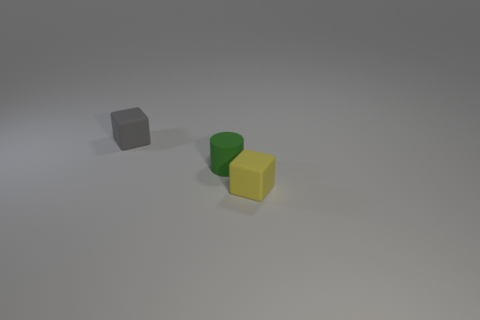Can you tell me the colors of the blocks and the cylinder? Certainly, there is a gray block, a yellow cube, and a green cylinder in the image. 